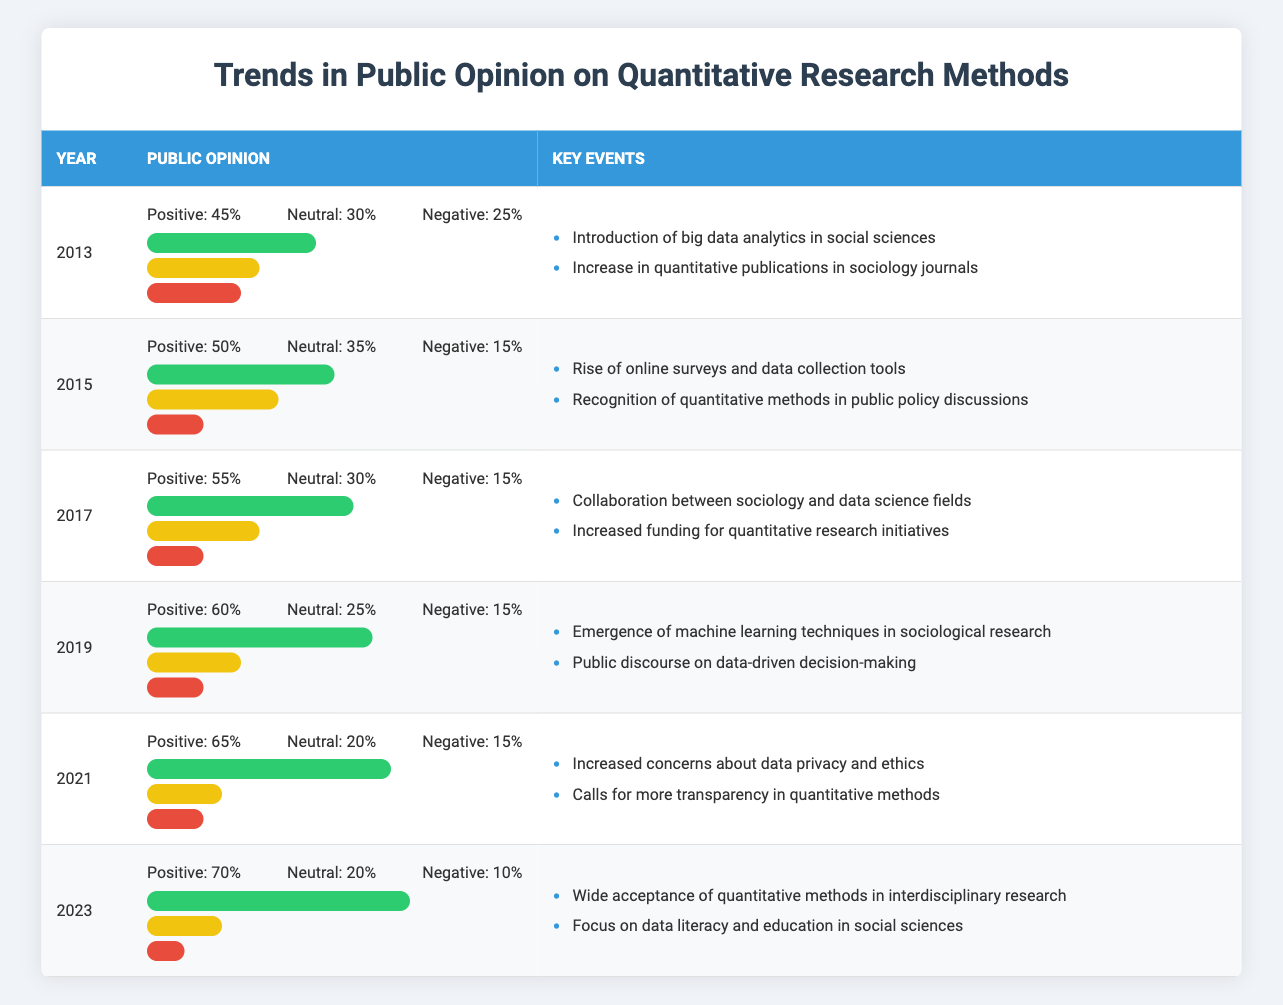What was the percentage of positive public opinion in 2015? Referring to the table for the year 2015, the public opinion shows Positive: 50%.
Answer: 50% What are the key events that occurred in 2021? The table for the year 2021 lists the key events as: Increased concerns about data privacy and ethics and Calls for more transparency in quantitative methods.
Answer: Increased concerns about data privacy and ethics; Calls for more transparency in quantitative methods What was the increase in positive public opinion from 2013 to 2023? In 2013, the positive public opinion was 45%, and in 2023, it was 70%. The increase is calculated as 70% - 45% = 25%.
Answer: 25% Is it true that the negative public opinion percentage has decreased over the years? Checking each year in the table, the negative public opinion percentages are 25%, 15%, 15%, 15%, 15%, and 10% from 2013 to 2023, showing a consistent decrease.
Answer: Yes Which year had the highest percentage of neutral public opinion? The table indicates that 2015 had the highest neutral public opinion at 35%.
Answer: 2015 What is the average percentage of positive public opinion from 2013 to 2023? Adding the positive percentages from each year gives: 45 + 50 + 55 + 60 + 65 + 70 = 345. There are 6 data points; thus, the average is 345 / 6 = 57.5%.
Answer: 57.5% What were the public opinion percentages in 2019? Referring to the 2019 row in the table, the public opinions are Positive: 60%, Neutral: 25%, Negative: 15%.
Answer: Positive: 60%; Neutral: 25%; Negative: 15% Was there a significant event related to the rise of data analytics in 2013? Yes, the introduction of big data analytics in social sciences is listed as a key event for that year.
Answer: Yes 